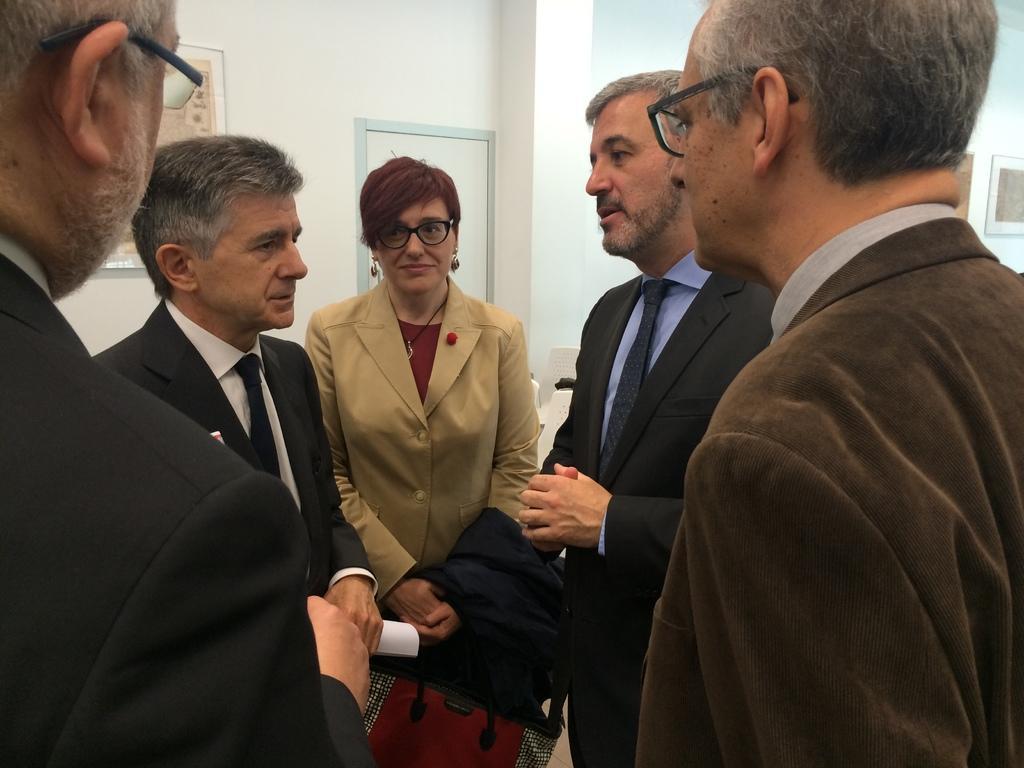Can you describe this image briefly? In this image we can see four men wearing the suits. We can also see a woman wearing the glasses and also the suit and holding the bag and standing. In the background we can see the wall, door and also the frames attached to the plain wall. 